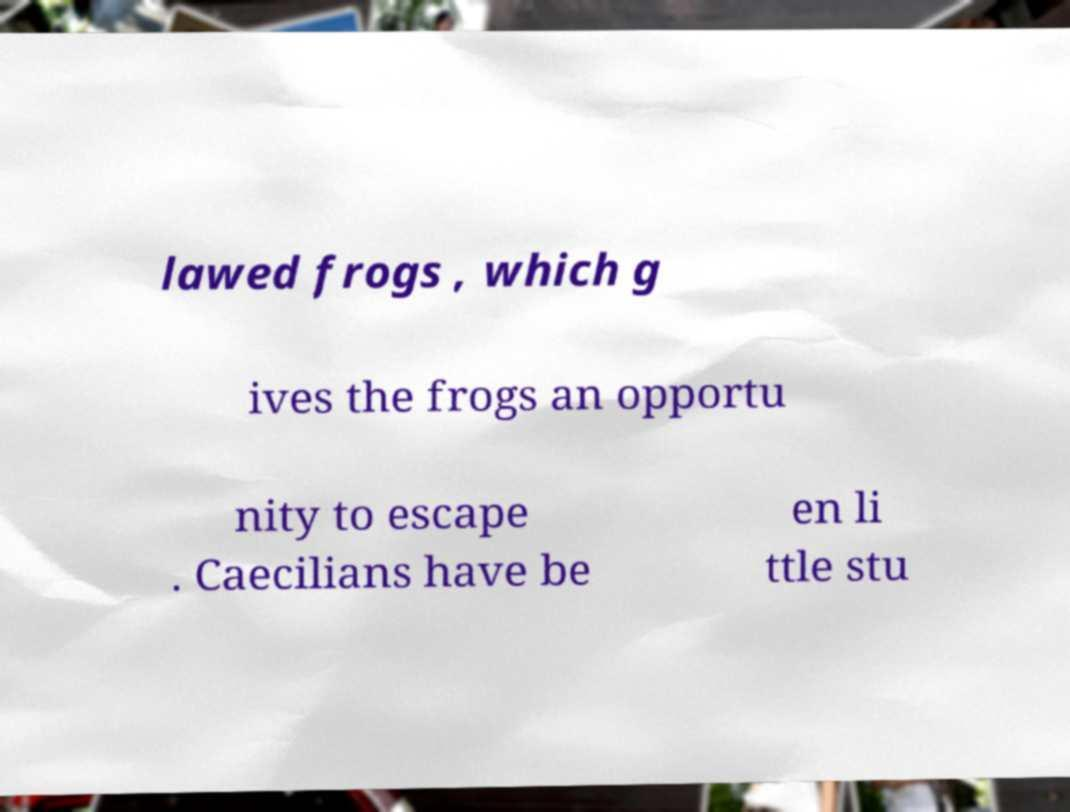Can you read and provide the text displayed in the image?This photo seems to have some interesting text. Can you extract and type it out for me? lawed frogs , which g ives the frogs an opportu nity to escape . Caecilians have be en li ttle stu 